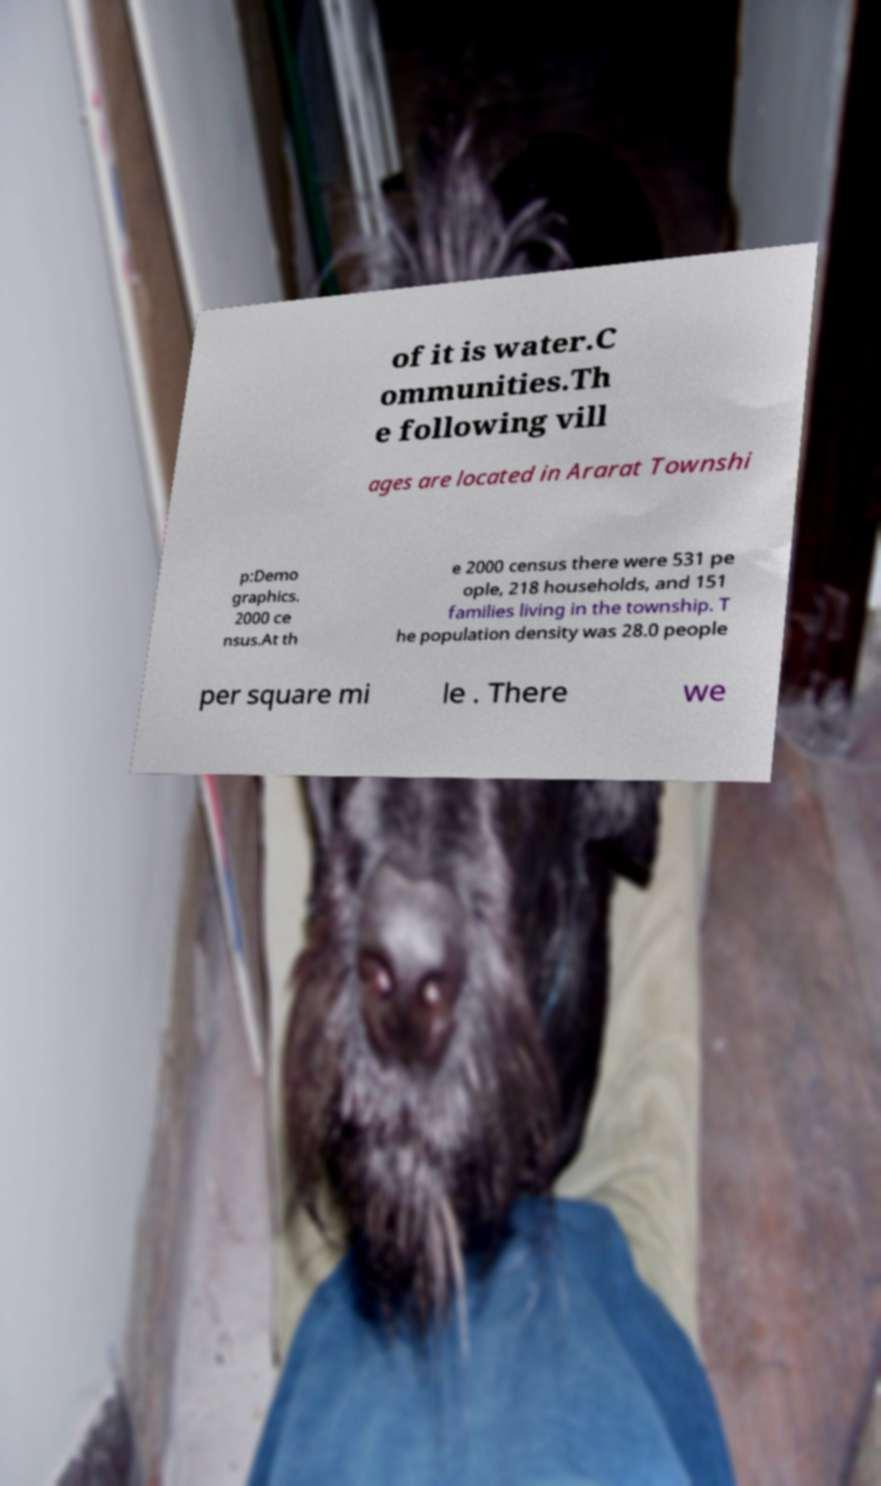I need the written content from this picture converted into text. Can you do that? of it is water.C ommunities.Th e following vill ages are located in Ararat Townshi p:Demo graphics. 2000 ce nsus.At th e 2000 census there were 531 pe ople, 218 households, and 151 families living in the township. T he population density was 28.0 people per square mi le . There we 